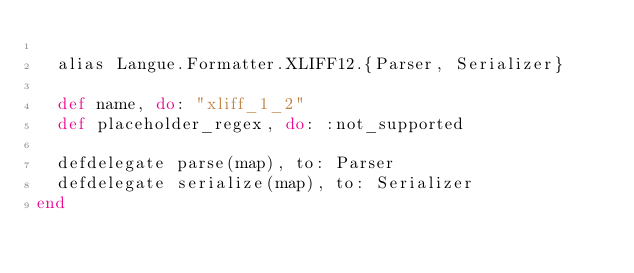Convert code to text. <code><loc_0><loc_0><loc_500><loc_500><_Elixir_>
  alias Langue.Formatter.XLIFF12.{Parser, Serializer}

  def name, do: "xliff_1_2"
  def placeholder_regex, do: :not_supported

  defdelegate parse(map), to: Parser
  defdelegate serialize(map), to: Serializer
end
</code> 